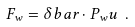Convert formula to latex. <formula><loc_0><loc_0><loc_500><loc_500>F _ { w } = \delta b a r \cdot P _ { w } u \ .</formula> 